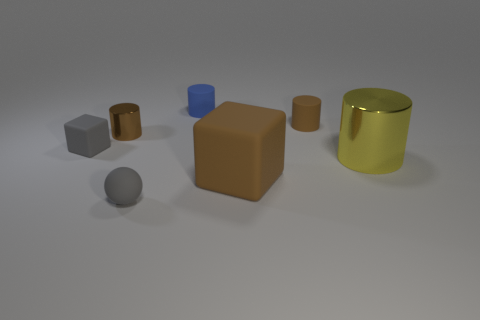Add 1 tiny yellow rubber cubes. How many objects exist? 8 Subtract all blocks. How many objects are left? 5 Subtract 0 yellow spheres. How many objects are left? 7 Subtract all tiny gray objects. Subtract all tiny matte things. How many objects are left? 1 Add 3 big things. How many big things are left? 5 Add 2 big purple metal cylinders. How many big purple metal cylinders exist? 2 